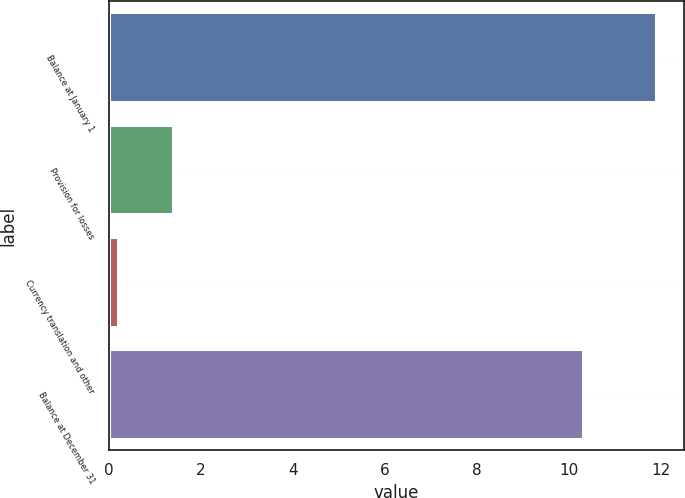Convert chart to OTSL. <chart><loc_0><loc_0><loc_500><loc_500><bar_chart><fcel>Balance at January 1<fcel>Provision for losses<fcel>Currency translation and other<fcel>Balance at December 31<nl><fcel>11.9<fcel>1.4<fcel>0.2<fcel>10.3<nl></chart> 